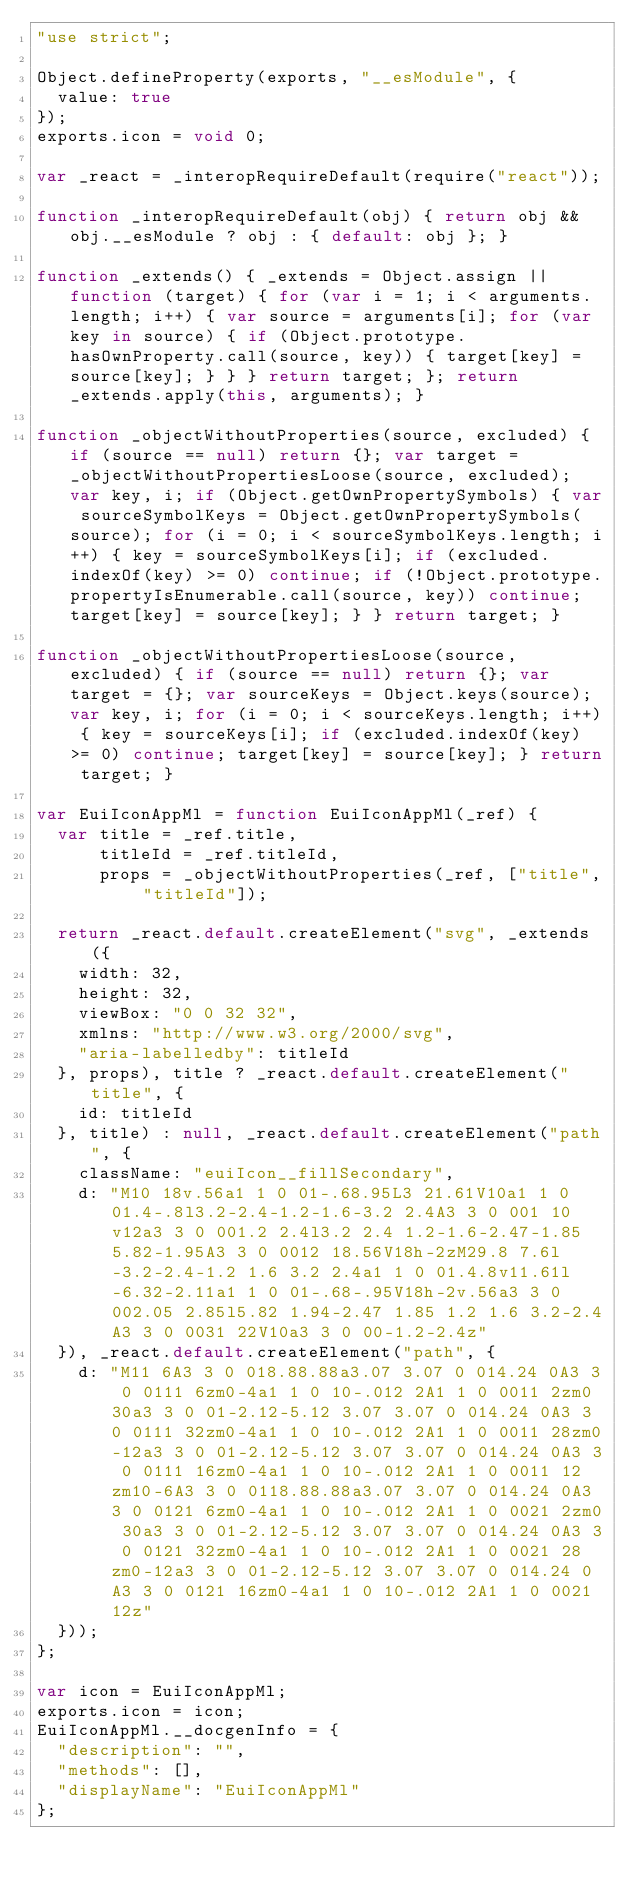Convert code to text. <code><loc_0><loc_0><loc_500><loc_500><_JavaScript_>"use strict";

Object.defineProperty(exports, "__esModule", {
  value: true
});
exports.icon = void 0;

var _react = _interopRequireDefault(require("react"));

function _interopRequireDefault(obj) { return obj && obj.__esModule ? obj : { default: obj }; }

function _extends() { _extends = Object.assign || function (target) { for (var i = 1; i < arguments.length; i++) { var source = arguments[i]; for (var key in source) { if (Object.prototype.hasOwnProperty.call(source, key)) { target[key] = source[key]; } } } return target; }; return _extends.apply(this, arguments); }

function _objectWithoutProperties(source, excluded) { if (source == null) return {}; var target = _objectWithoutPropertiesLoose(source, excluded); var key, i; if (Object.getOwnPropertySymbols) { var sourceSymbolKeys = Object.getOwnPropertySymbols(source); for (i = 0; i < sourceSymbolKeys.length; i++) { key = sourceSymbolKeys[i]; if (excluded.indexOf(key) >= 0) continue; if (!Object.prototype.propertyIsEnumerable.call(source, key)) continue; target[key] = source[key]; } } return target; }

function _objectWithoutPropertiesLoose(source, excluded) { if (source == null) return {}; var target = {}; var sourceKeys = Object.keys(source); var key, i; for (i = 0; i < sourceKeys.length; i++) { key = sourceKeys[i]; if (excluded.indexOf(key) >= 0) continue; target[key] = source[key]; } return target; }

var EuiIconAppMl = function EuiIconAppMl(_ref) {
  var title = _ref.title,
      titleId = _ref.titleId,
      props = _objectWithoutProperties(_ref, ["title", "titleId"]);

  return _react.default.createElement("svg", _extends({
    width: 32,
    height: 32,
    viewBox: "0 0 32 32",
    xmlns: "http://www.w3.org/2000/svg",
    "aria-labelledby": titleId
  }, props), title ? _react.default.createElement("title", {
    id: titleId
  }, title) : null, _react.default.createElement("path", {
    className: "euiIcon__fillSecondary",
    d: "M10 18v.56a1 1 0 01-.68.95L3 21.61V10a1 1 0 01.4-.8l3.2-2.4-1.2-1.6-3.2 2.4A3 3 0 001 10v12a3 3 0 001.2 2.4l3.2 2.4 1.2-1.6-2.47-1.85 5.82-1.95A3 3 0 0012 18.56V18h-2zM29.8 7.6l-3.2-2.4-1.2 1.6 3.2 2.4a1 1 0 01.4.8v11.61l-6.32-2.11a1 1 0 01-.68-.95V18h-2v.56a3 3 0 002.05 2.85l5.82 1.94-2.47 1.85 1.2 1.6 3.2-2.4A3 3 0 0031 22V10a3 3 0 00-1.2-2.4z"
  }), _react.default.createElement("path", {
    d: "M11 6A3 3 0 018.88.88a3.07 3.07 0 014.24 0A3 3 0 0111 6zm0-4a1 1 0 10-.012 2A1 1 0 0011 2zm0 30a3 3 0 01-2.12-5.12 3.07 3.07 0 014.24 0A3 3 0 0111 32zm0-4a1 1 0 10-.012 2A1 1 0 0011 28zm0-12a3 3 0 01-2.12-5.12 3.07 3.07 0 014.24 0A3 3 0 0111 16zm0-4a1 1 0 10-.012 2A1 1 0 0011 12zm10-6A3 3 0 0118.88.88a3.07 3.07 0 014.24 0A3 3 0 0121 6zm0-4a1 1 0 10-.012 2A1 1 0 0021 2zm0 30a3 3 0 01-2.12-5.12 3.07 3.07 0 014.24 0A3 3 0 0121 32zm0-4a1 1 0 10-.012 2A1 1 0 0021 28zm0-12a3 3 0 01-2.12-5.12 3.07 3.07 0 014.24 0A3 3 0 0121 16zm0-4a1 1 0 10-.012 2A1 1 0 0021 12z"
  }));
};

var icon = EuiIconAppMl;
exports.icon = icon;
EuiIconAppMl.__docgenInfo = {
  "description": "",
  "methods": [],
  "displayName": "EuiIconAppMl"
};</code> 